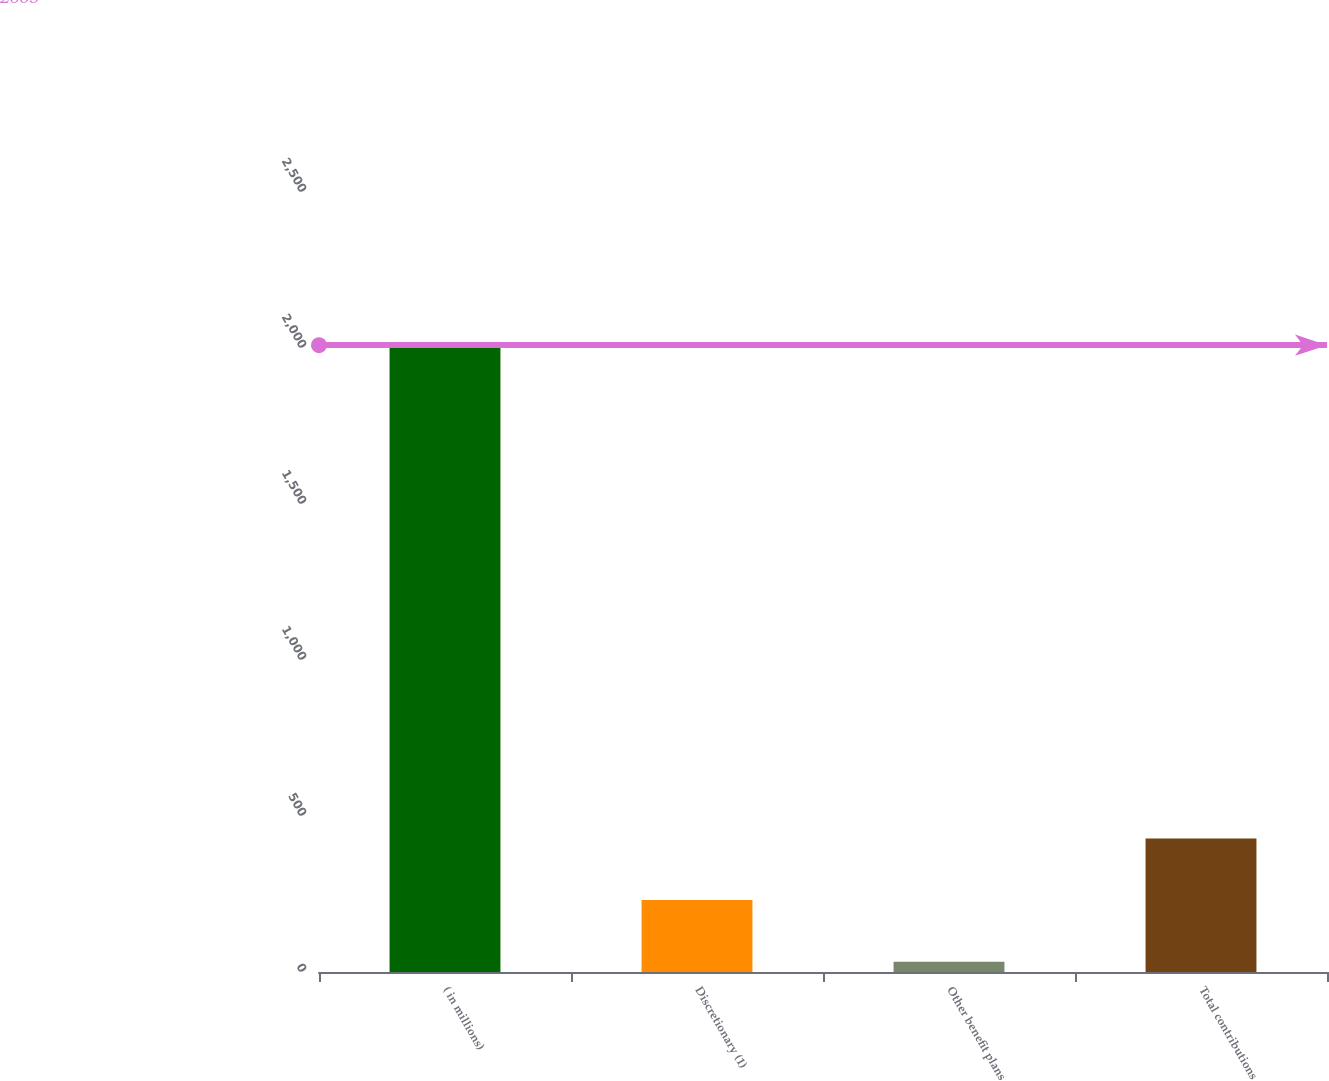Convert chart. <chart><loc_0><loc_0><loc_500><loc_500><bar_chart><fcel>( in millions)<fcel>Discretionary (1)<fcel>Other benefit plans<fcel>Total contributions<nl><fcel>2009<fcel>230.6<fcel>33<fcel>428.2<nl></chart> 